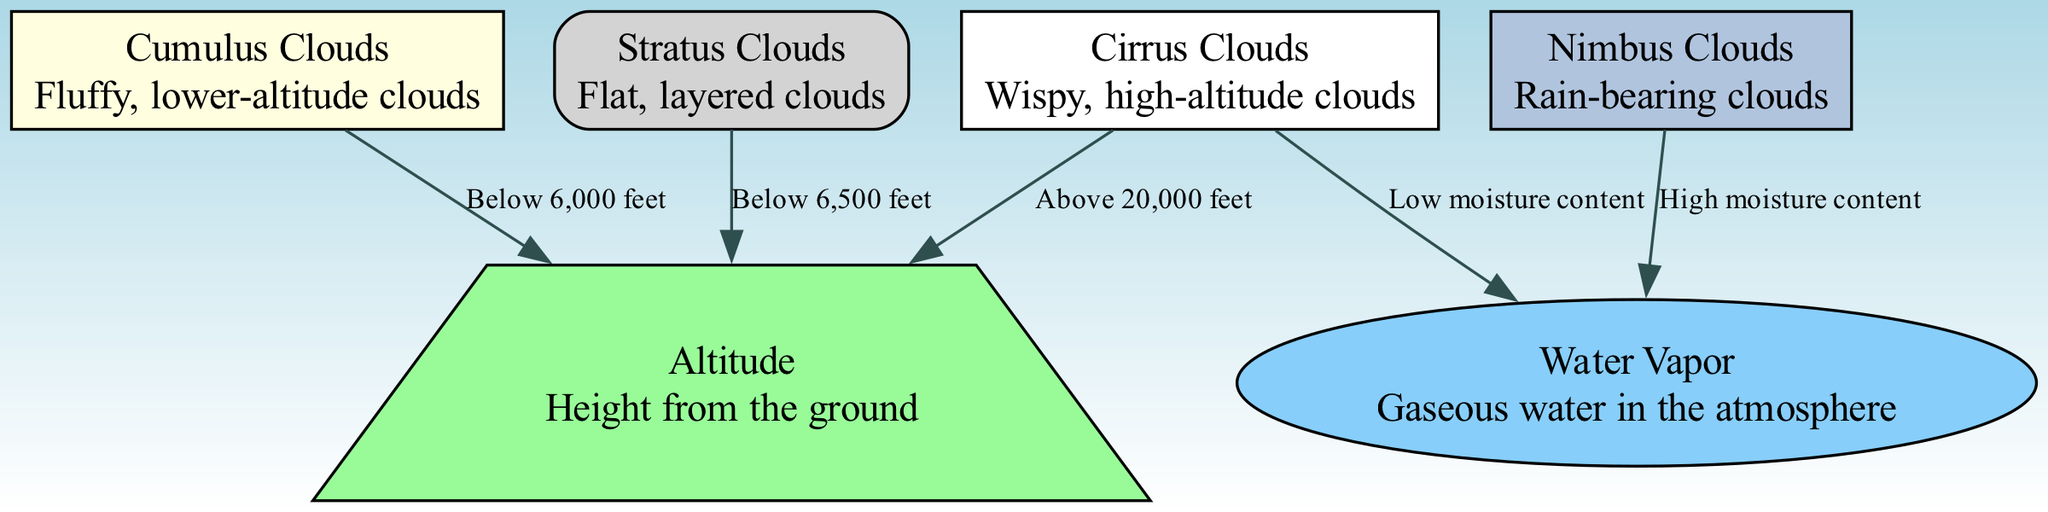What type of cloud is described as wispy and high-altitude? The diagram indicates that "Cirrus Clouds" are characterized as "wispy" and located at high altitudes.
Answer: Cirrus Clouds Which cloud type has a moisture content classified as low? According to the diagram, "Cirrus Clouds" are connected to "Water Vapor" with the description stating it has "Low moisture content."
Answer: Low What is the altitude range for Cumulus Clouds? The diagram shows that Cumulus Clouds are found "Below 6,000 feet."
Answer: Below 6,000 feet How many cloud types are mentioned in the diagram? By counting the listed nodes in the diagram, there are a total of four distinct cloud types: Cirrus, Cumulus, Stratus, and Nimbus.
Answer: Four Which cloud type is associated with high moisture content? The diagram links "Nimbus Clouds" to "Water Vapor" with the label "High moisture content," indicating the relationship.
Answer: Nimbus Clouds What altitude do Stratus Clouds generally exist below? The diagram specifies that Stratus Clouds are located "Below 6,500 feet," making that the altitude range for this cloud type.
Answer: Below 6,500 feet What is the relationship between Cirrus Clouds and Water Vapor? The diagram reveals that Cirrus Clouds are connected to Water Vapor with a description indicating "Low moisture content," highlighting the relationship.
Answer: Low moisture content Which cloud type is described as flat and layered? The diagram clearly labels Stratus Clouds with the description "Flat, layered clouds," identifying this characteristic.
Answer: Stratus Clouds What type of diagram is this that illustrates cloud types? The title of the diagram indicates that it is a "Natural Science Diagram" centered on the "Structure and Function of Different Cloud Types."
Answer: Natural Science Diagram 